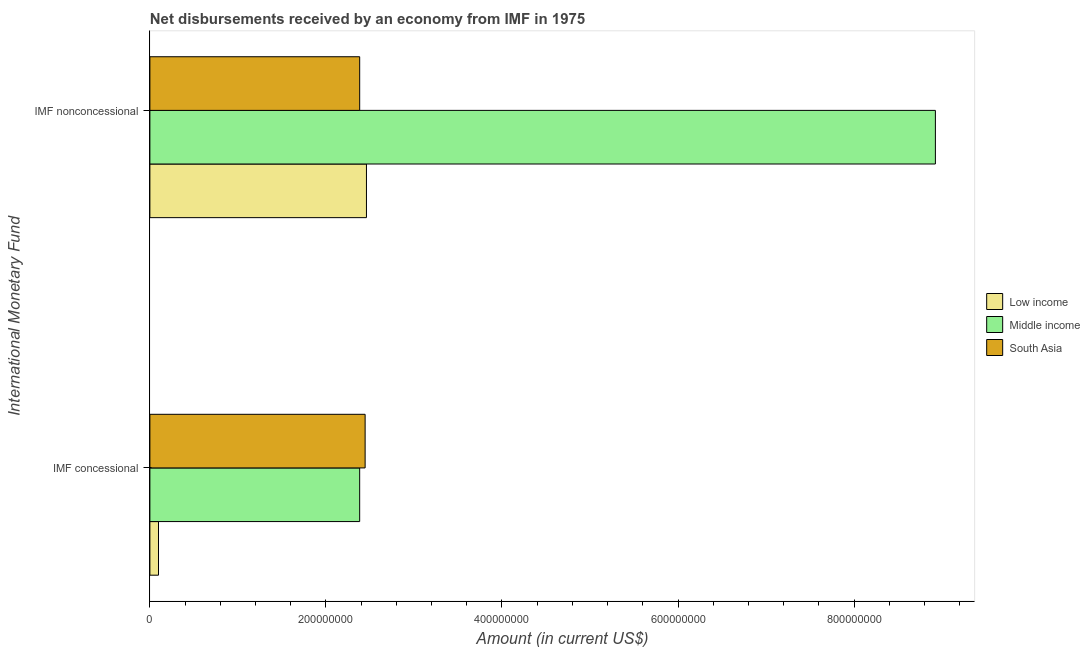Are the number of bars per tick equal to the number of legend labels?
Provide a short and direct response. Yes. How many bars are there on the 1st tick from the top?
Your answer should be compact. 3. How many bars are there on the 1st tick from the bottom?
Keep it short and to the point. 3. What is the label of the 1st group of bars from the top?
Keep it short and to the point. IMF nonconcessional. What is the net concessional disbursements from imf in Low income?
Keep it short and to the point. 9.77e+06. Across all countries, what is the maximum net concessional disbursements from imf?
Give a very brief answer. 2.45e+08. Across all countries, what is the minimum net concessional disbursements from imf?
Your answer should be compact. 9.77e+06. In which country was the net concessional disbursements from imf maximum?
Your answer should be compact. South Asia. In which country was the net concessional disbursements from imf minimum?
Provide a short and direct response. Low income. What is the total net non concessional disbursements from imf in the graph?
Provide a short and direct response. 1.38e+09. What is the difference between the net non concessional disbursements from imf in Low income and that in South Asia?
Your response must be concise. 7.69e+06. What is the difference between the net non concessional disbursements from imf in Middle income and the net concessional disbursements from imf in Low income?
Keep it short and to the point. 8.83e+08. What is the average net concessional disbursements from imf per country?
Give a very brief answer. 1.64e+08. What is the difference between the net non concessional disbursements from imf and net concessional disbursements from imf in Middle income?
Offer a terse response. 6.54e+08. In how many countries, is the net concessional disbursements from imf greater than 160000000 US$?
Give a very brief answer. 2. What is the ratio of the net concessional disbursements from imf in Low income to that in Middle income?
Your response must be concise. 0.04. How many bars are there?
Provide a short and direct response. 6. Are all the bars in the graph horizontal?
Your response must be concise. Yes. Does the graph contain any zero values?
Offer a terse response. No. Does the graph contain grids?
Provide a succinct answer. No. What is the title of the graph?
Your response must be concise. Net disbursements received by an economy from IMF in 1975. Does "Slovenia" appear as one of the legend labels in the graph?
Make the answer very short. No. What is the label or title of the Y-axis?
Offer a terse response. International Monetary Fund. What is the Amount (in current US$) in Low income in IMF concessional?
Provide a succinct answer. 9.77e+06. What is the Amount (in current US$) of Middle income in IMF concessional?
Keep it short and to the point. 2.38e+08. What is the Amount (in current US$) of South Asia in IMF concessional?
Keep it short and to the point. 2.45e+08. What is the Amount (in current US$) in Low income in IMF nonconcessional?
Ensure brevity in your answer.  2.46e+08. What is the Amount (in current US$) of Middle income in IMF nonconcessional?
Your answer should be compact. 8.92e+08. What is the Amount (in current US$) in South Asia in IMF nonconcessional?
Keep it short and to the point. 2.38e+08. Across all International Monetary Fund, what is the maximum Amount (in current US$) of Low income?
Your answer should be very brief. 2.46e+08. Across all International Monetary Fund, what is the maximum Amount (in current US$) in Middle income?
Your response must be concise. 8.92e+08. Across all International Monetary Fund, what is the maximum Amount (in current US$) of South Asia?
Provide a succinct answer. 2.45e+08. Across all International Monetary Fund, what is the minimum Amount (in current US$) in Low income?
Give a very brief answer. 9.77e+06. Across all International Monetary Fund, what is the minimum Amount (in current US$) in Middle income?
Give a very brief answer. 2.38e+08. Across all International Monetary Fund, what is the minimum Amount (in current US$) in South Asia?
Provide a succinct answer. 2.38e+08. What is the total Amount (in current US$) in Low income in the graph?
Your response must be concise. 2.56e+08. What is the total Amount (in current US$) in Middle income in the graph?
Provide a succinct answer. 1.13e+09. What is the total Amount (in current US$) in South Asia in the graph?
Make the answer very short. 4.83e+08. What is the difference between the Amount (in current US$) in Low income in IMF concessional and that in IMF nonconcessional?
Make the answer very short. -2.36e+08. What is the difference between the Amount (in current US$) in Middle income in IMF concessional and that in IMF nonconcessional?
Offer a terse response. -6.54e+08. What is the difference between the Amount (in current US$) in South Asia in IMF concessional and that in IMF nonconcessional?
Keep it short and to the point. 6.19e+06. What is the difference between the Amount (in current US$) in Low income in IMF concessional and the Amount (in current US$) in Middle income in IMF nonconcessional?
Your answer should be compact. -8.83e+08. What is the difference between the Amount (in current US$) in Low income in IMF concessional and the Amount (in current US$) in South Asia in IMF nonconcessional?
Your answer should be very brief. -2.29e+08. What is the difference between the Amount (in current US$) in Middle income in IMF concessional and the Amount (in current US$) in South Asia in IMF nonconcessional?
Give a very brief answer. -8503. What is the average Amount (in current US$) in Low income per International Monetary Fund?
Offer a very short reply. 1.28e+08. What is the average Amount (in current US$) in Middle income per International Monetary Fund?
Offer a terse response. 5.65e+08. What is the average Amount (in current US$) of South Asia per International Monetary Fund?
Your response must be concise. 2.41e+08. What is the difference between the Amount (in current US$) of Low income and Amount (in current US$) of Middle income in IMF concessional?
Give a very brief answer. -2.29e+08. What is the difference between the Amount (in current US$) in Low income and Amount (in current US$) in South Asia in IMF concessional?
Offer a very short reply. -2.35e+08. What is the difference between the Amount (in current US$) in Middle income and Amount (in current US$) in South Asia in IMF concessional?
Offer a terse response. -6.20e+06. What is the difference between the Amount (in current US$) in Low income and Amount (in current US$) in Middle income in IMF nonconcessional?
Your answer should be very brief. -6.46e+08. What is the difference between the Amount (in current US$) in Low income and Amount (in current US$) in South Asia in IMF nonconcessional?
Your answer should be very brief. 7.69e+06. What is the difference between the Amount (in current US$) in Middle income and Amount (in current US$) in South Asia in IMF nonconcessional?
Offer a very short reply. 6.54e+08. What is the ratio of the Amount (in current US$) of Low income in IMF concessional to that in IMF nonconcessional?
Make the answer very short. 0.04. What is the ratio of the Amount (in current US$) of Middle income in IMF concessional to that in IMF nonconcessional?
Ensure brevity in your answer.  0.27. What is the difference between the highest and the second highest Amount (in current US$) of Low income?
Offer a terse response. 2.36e+08. What is the difference between the highest and the second highest Amount (in current US$) in Middle income?
Offer a very short reply. 6.54e+08. What is the difference between the highest and the second highest Amount (in current US$) of South Asia?
Your answer should be compact. 6.19e+06. What is the difference between the highest and the lowest Amount (in current US$) in Low income?
Keep it short and to the point. 2.36e+08. What is the difference between the highest and the lowest Amount (in current US$) of Middle income?
Offer a very short reply. 6.54e+08. What is the difference between the highest and the lowest Amount (in current US$) in South Asia?
Give a very brief answer. 6.19e+06. 